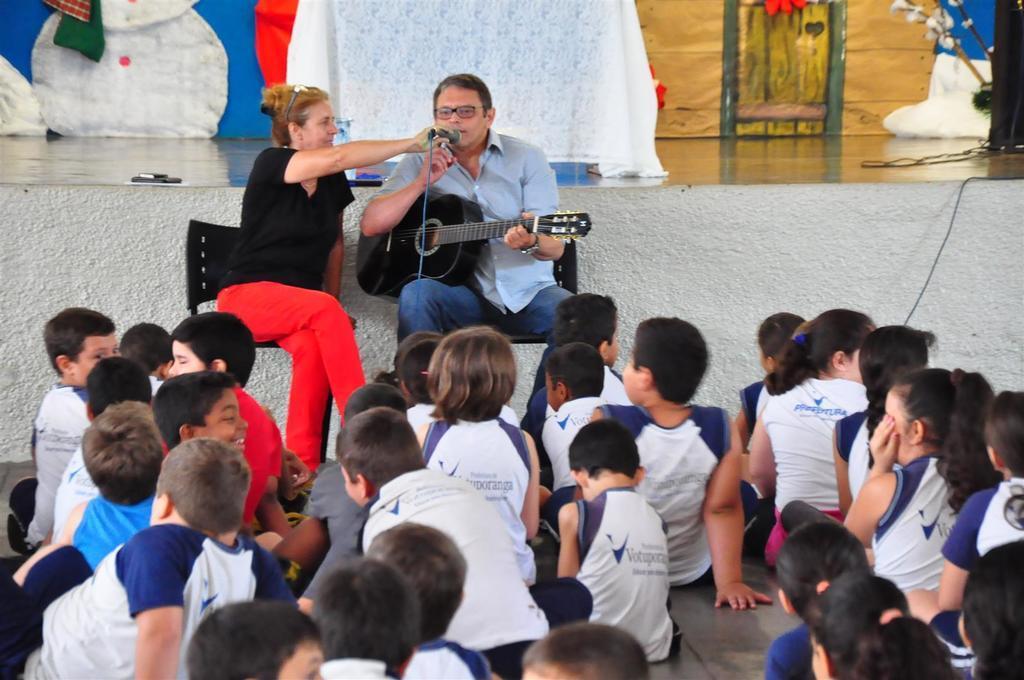Could you give a brief overview of what you see in this image? Most of the kids are sitting on a floor. Front this 2 persons are sitting on a chair. This person is holding a guitar and singing in-front of mic. This woman is holding a mic. 